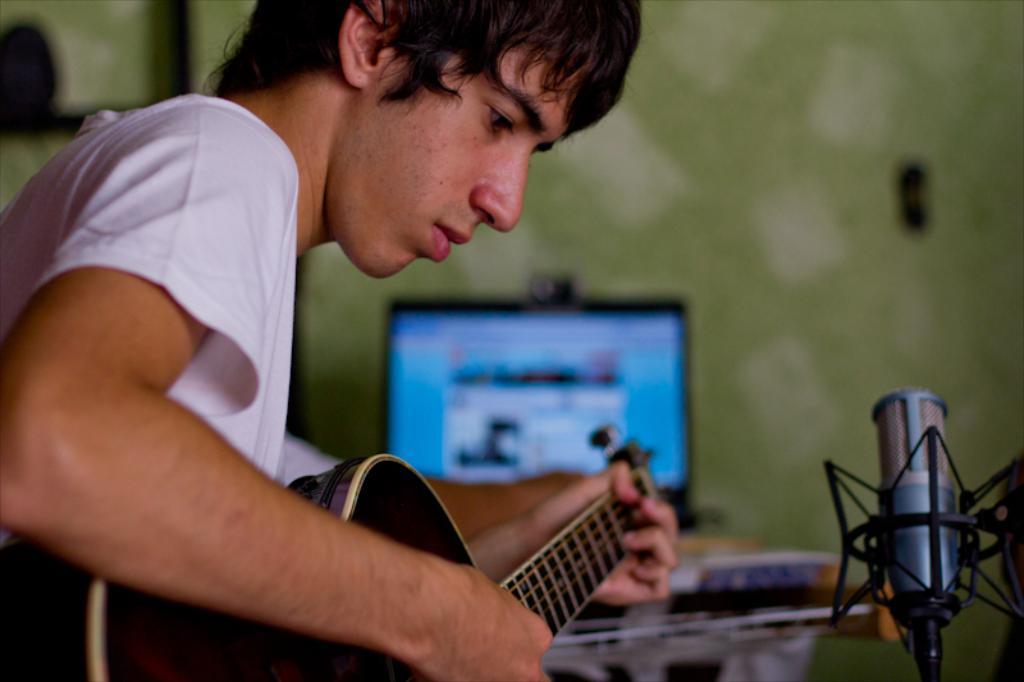Please provide a concise description of this image. This man wore white t-shirt and playing a guitar. Far there is a monitor on a table. This is mic. 